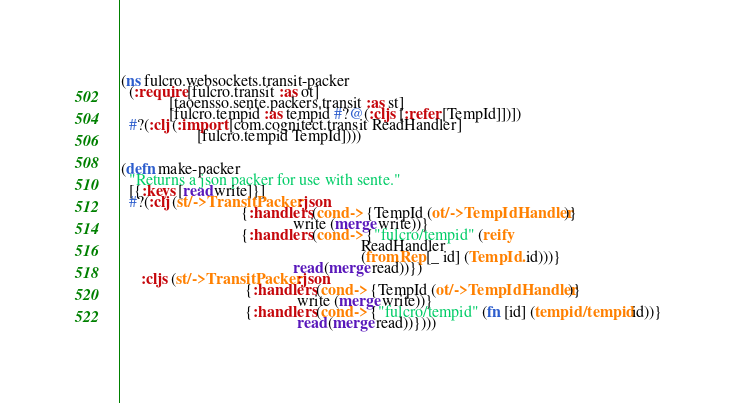<code> <loc_0><loc_0><loc_500><loc_500><_Clojure_>(ns fulcro.websockets.transit-packer
  (:require [fulcro.transit :as ot]
            [taoensso.sente.packers.transit :as st]
            [fulcro.tempid :as tempid #?@(:cljs [:refer [TempId]])])
  #?(:clj (:import [com.cognitect.transit ReadHandler]
                   [fulcro.tempid TempId])))


(defn make-packer
  "Returns a json packer for use with sente."
  [{:keys [read write]}]
  #?(:clj (st/->TransitPacker :json
                              {:handlers (cond-> {TempId (ot/->TempIdHandler)}
                                           write (merge write))}
                              {:handlers (cond-> {"fulcro/tempid" (reify
                                                            ReadHandler
                                                            (fromRep [_ id] (TempId. id)))}
                                           read (merge read))})
     :cljs (st/->TransitPacker :json
                               {:handlers (cond-> {TempId (ot/->TempIdHandler)}
                                            write (merge write))}
                               {:handlers (cond-> {"fulcro/tempid" (fn [id] (tempid/tempid id))}
                                            read (merge read))})))
</code> 